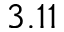<formula> <loc_0><loc_0><loc_500><loc_500>3 . 1 1</formula> 